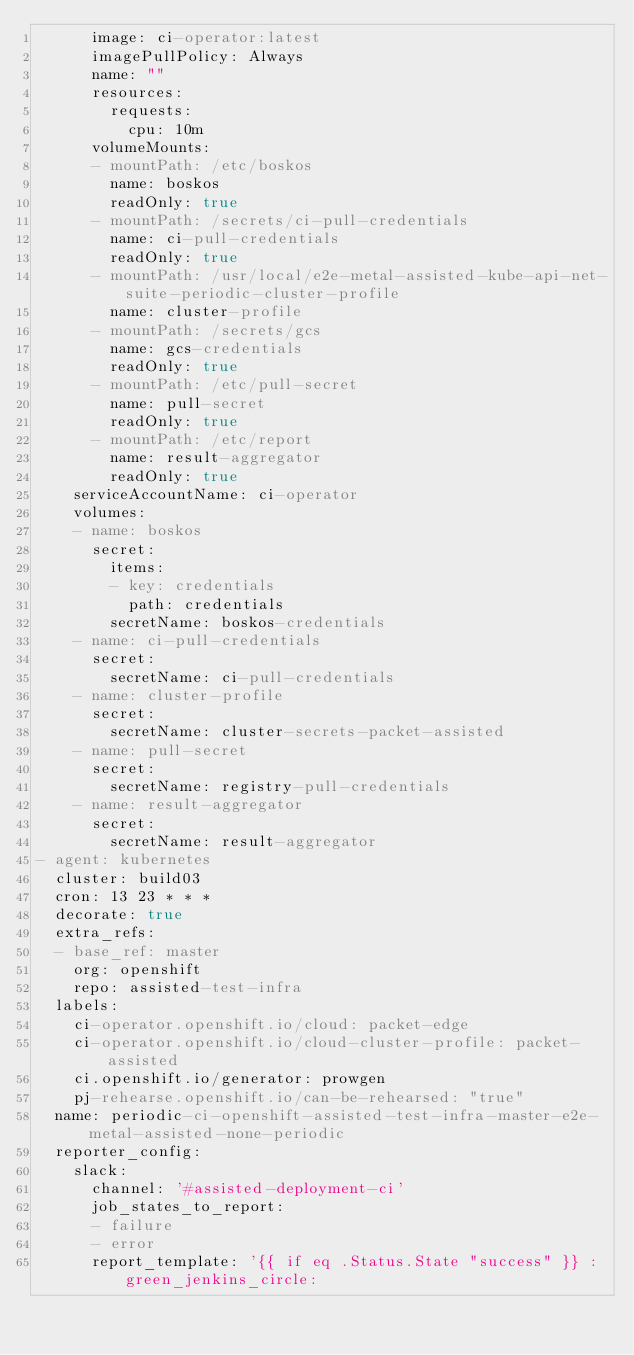Convert code to text. <code><loc_0><loc_0><loc_500><loc_500><_YAML_>      image: ci-operator:latest
      imagePullPolicy: Always
      name: ""
      resources:
        requests:
          cpu: 10m
      volumeMounts:
      - mountPath: /etc/boskos
        name: boskos
        readOnly: true
      - mountPath: /secrets/ci-pull-credentials
        name: ci-pull-credentials
        readOnly: true
      - mountPath: /usr/local/e2e-metal-assisted-kube-api-net-suite-periodic-cluster-profile
        name: cluster-profile
      - mountPath: /secrets/gcs
        name: gcs-credentials
        readOnly: true
      - mountPath: /etc/pull-secret
        name: pull-secret
        readOnly: true
      - mountPath: /etc/report
        name: result-aggregator
        readOnly: true
    serviceAccountName: ci-operator
    volumes:
    - name: boskos
      secret:
        items:
        - key: credentials
          path: credentials
        secretName: boskos-credentials
    - name: ci-pull-credentials
      secret:
        secretName: ci-pull-credentials
    - name: cluster-profile
      secret:
        secretName: cluster-secrets-packet-assisted
    - name: pull-secret
      secret:
        secretName: registry-pull-credentials
    - name: result-aggregator
      secret:
        secretName: result-aggregator
- agent: kubernetes
  cluster: build03
  cron: 13 23 * * *
  decorate: true
  extra_refs:
  - base_ref: master
    org: openshift
    repo: assisted-test-infra
  labels:
    ci-operator.openshift.io/cloud: packet-edge
    ci-operator.openshift.io/cloud-cluster-profile: packet-assisted
    ci.openshift.io/generator: prowgen
    pj-rehearse.openshift.io/can-be-rehearsed: "true"
  name: periodic-ci-openshift-assisted-test-infra-master-e2e-metal-assisted-none-periodic
  reporter_config:
    slack:
      channel: '#assisted-deployment-ci'
      job_states_to_report:
      - failure
      - error
      report_template: '{{ if eq .Status.State "success" }} :green_jenkins_circle:</code> 